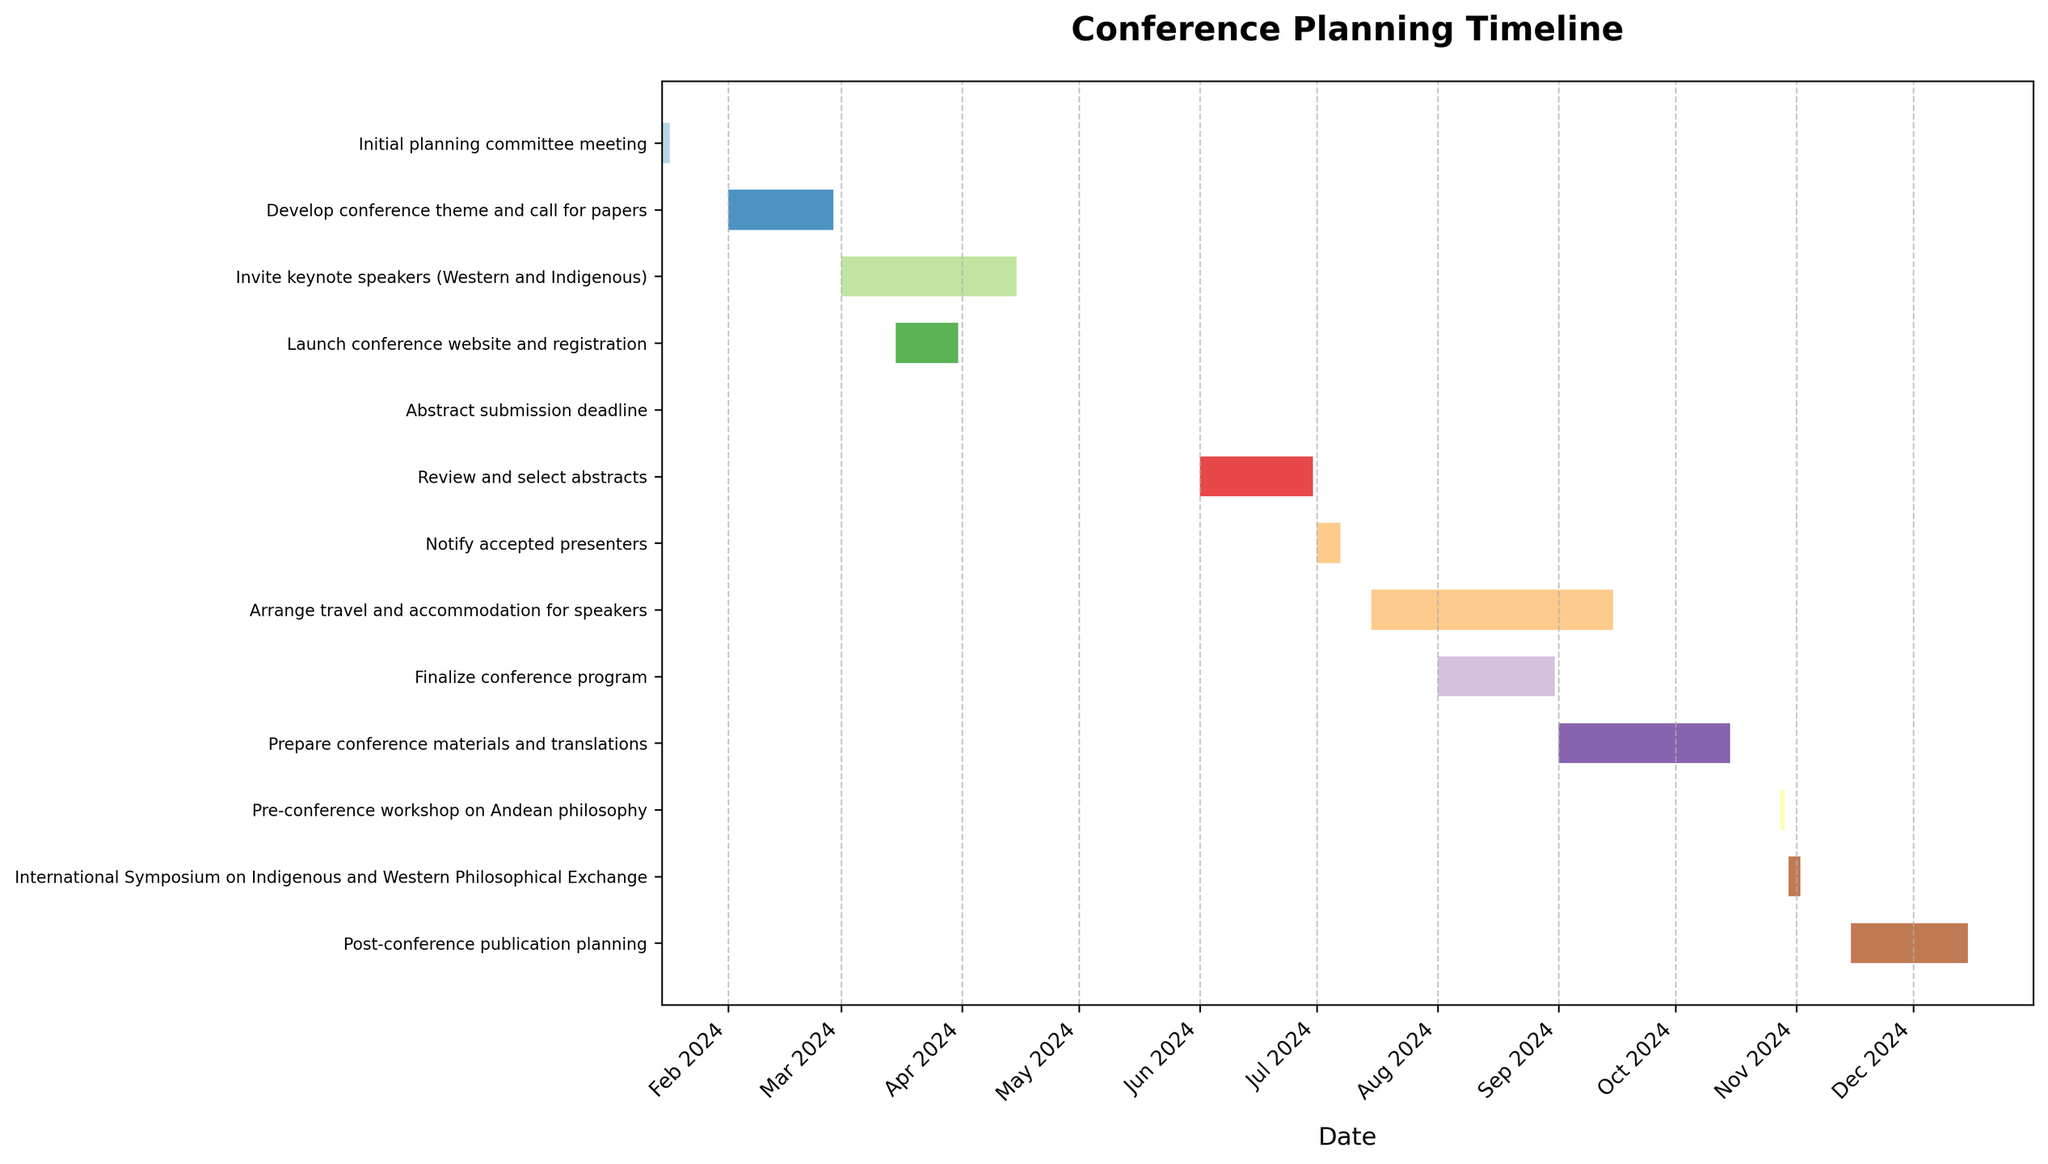How many tasks are listed in the conference planning timeline? Count the number of tasks displayed on the y-axis of the Gantt chart.
Answer: 13 When is the abstract submission deadline? Locate the task titled "Abstract submission deadline" and read the associated date from the x-axis.
Answer: May 31, 2024 Which task starts first, "Launch conference website and registration" or "Invite keynote speakers (Western and Indigenous)"? Identify the start dates of both tasks and compare them to see which one occurs earlier.
Answer: Invite keynote speakers (Western and Indigenous) How long does the "Arrange travel and accommodation for speakers" task last? Calculate the difference between the end date and start date of the specified task.
Answer: 62 days What are the start and end dates for the "International Symposium on Indigenous and Western Philosophical Exchange"? Find the task named "International Symposium on Indigenous and Western Philosophical Exchange" and note the start and end dates from the x-axis.
Answer: October 30, 2024 - November 2, 2024 Which task has the longest duration, and how many days does it span? Look up the duration (end date - start date) for each task and identify the one with the maximum duration.
Answer: Arrange travel and accommodation for speakers, 62 days What is the average duration of all tasks? Calculate the duration of each task and then find the average of these durations.
Answer: (2+27+45+16+1+30+6+62+30+45+2+4+30)/13 = 22.62 days Which tasks overlap with the "Develop conference theme and call for papers"? Identify tasks with start dates before the end date and end dates after the start date of the "Develop conference theme and call for papers" task.
Answer: Invite keynote speakers (Western and Indigenous), Launch conference website and registration When will the "Review and select abstracts" task be completed? Find the end date for the "Review and select abstracts" task in the Gantt chart.
Answer: June 30, 2024 Which period does the "Prepare conference materials and translations" cover? Find the start date and end date for the "Prepare conference materials and translations" task and note the period it spans.
Answer: September 1, 2024 - October 15, 2024 